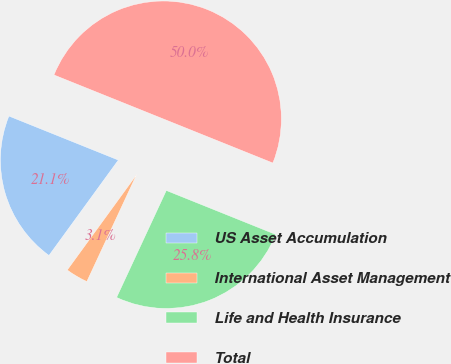Convert chart to OTSL. <chart><loc_0><loc_0><loc_500><loc_500><pie_chart><fcel>US Asset Accumulation<fcel>International Asset Management<fcel>Life and Health Insurance<fcel>Total<nl><fcel>21.08%<fcel>3.08%<fcel>25.84%<fcel>50.0%<nl></chart> 